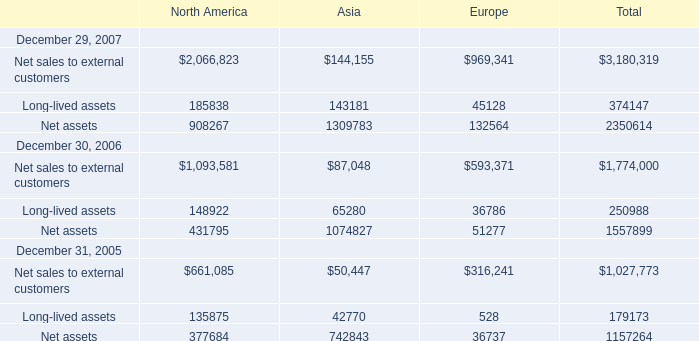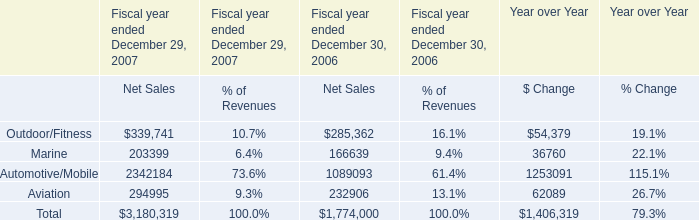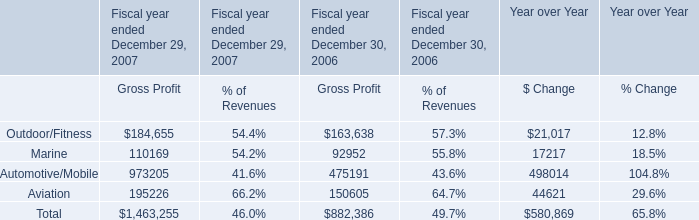What's the total amount of the Net sales to external customers in the years where Outdoor/Fitness for Gross Profit is greater than 100000? 
Computations: (2066823 + 1093581)
Answer: 3160404.0. 